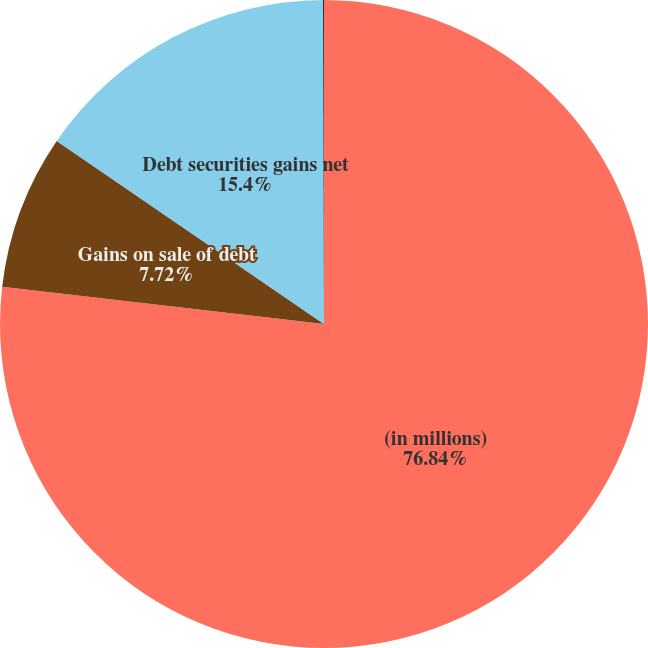<chart> <loc_0><loc_0><loc_500><loc_500><pie_chart><fcel>(in millions)<fcel>Gains on sale of debt<fcel>Debt securities gains net<fcel>Equity securities gains<nl><fcel>76.84%<fcel>7.72%<fcel>15.4%<fcel>0.04%<nl></chart> 